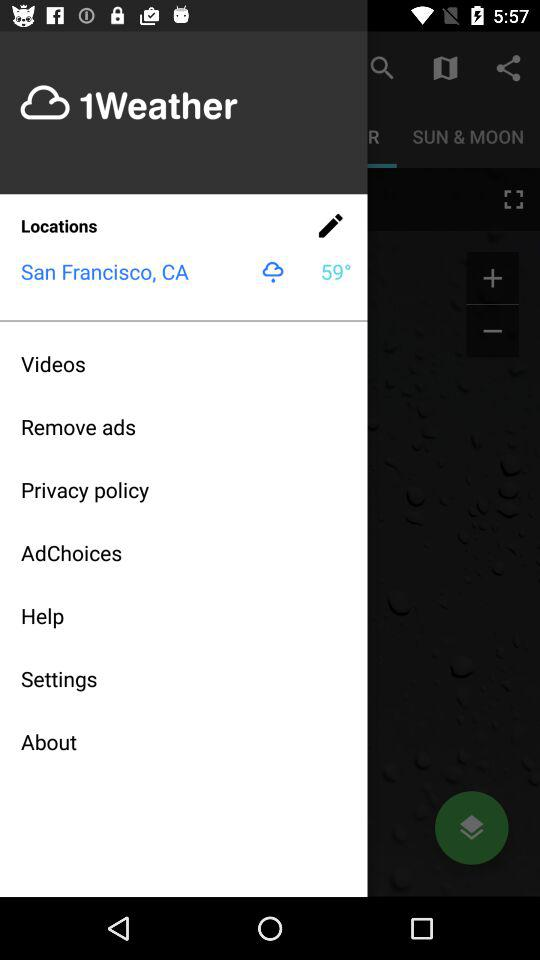What is the location? The location is San Francisco, CA. 